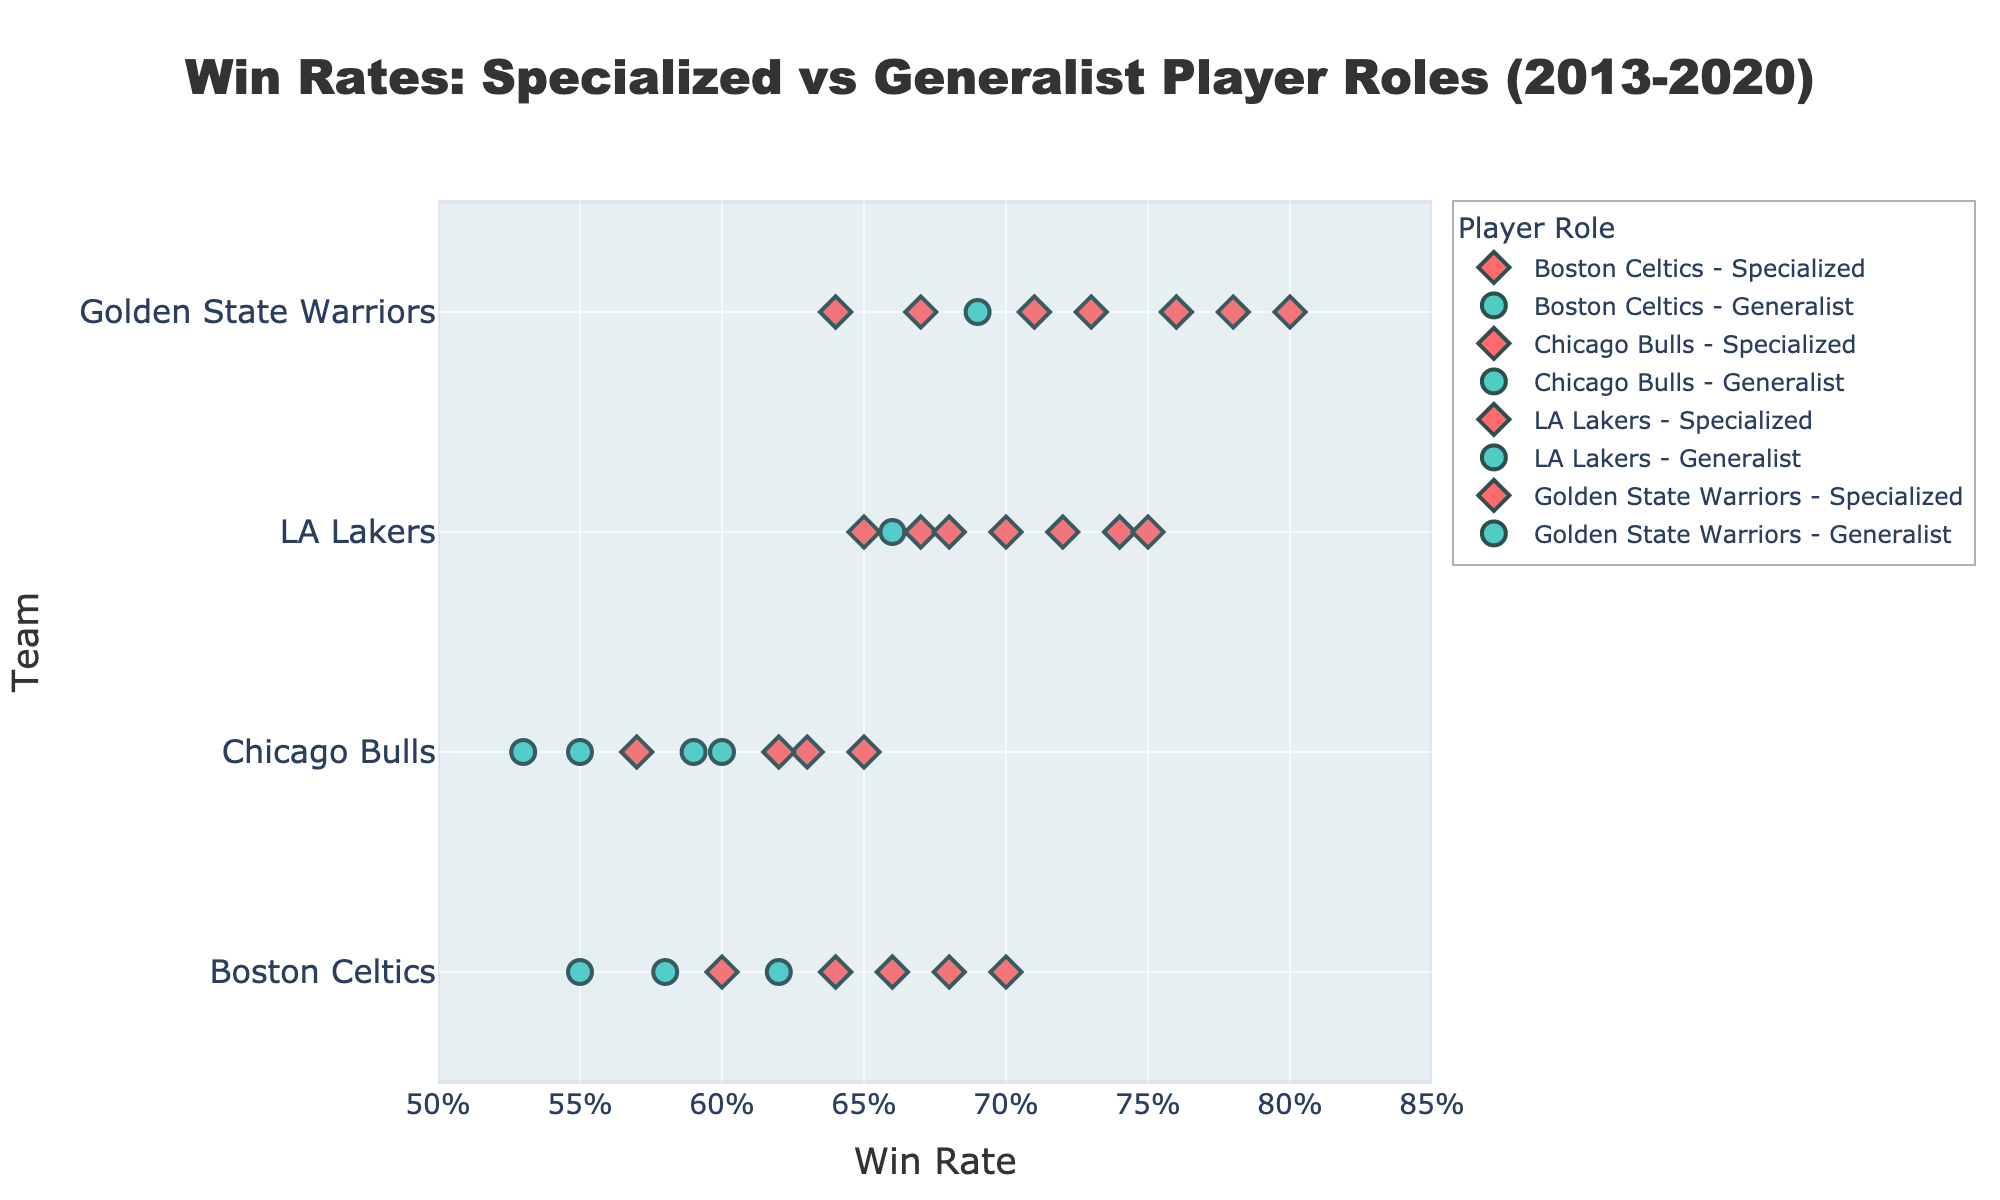Which team had the highest win rate with specialized player roles in 2020? To find the team with the highest win rate with specialized players in 2020, look for the data point in the figure representing specialized roles in 2020 and compare the win rates. The Golden State Warriors had the highest win rate with a specialized role at 0.71 in 2020.
Answer: Golden State Warriors What's the win rate difference between Chicago Bulls with specialized roles in 2014 and generalist roles in 2019? To calculate the win rate difference, find the win rates for Chicago Bulls in 2014 (specialized) and 2019 (generalist) from the figure. The win rates are 0.63 and 0.53, respectively. The difference is 0.63 - 0.53.
Answer: 0.10 Which team showed the most consistent win rates with specialized player roles over the period? Consistency can be observed by looking at the variation in win rates over the years for specialized player roles within each team. The LA Lakers have the least variation in their specialized win rates, ranging between 0.65 and 0.75 over the years.
Answer: LA Lakers Which team showed the largest improvement in win rate when switching from generalist to specialized roles? Identify the years each team switched from generalist to specialized roles in the figure, and calculate the win rate difference. Boston Celtics switched in 2016 with an increase from 0.58 (2015) to 0.66 (2016), amounting to an improvement of 0.08.
Answer: Boston Celtics How many years did the Golden State Warriors have specialized player roles from 2013 to 2020? Count the number of years shown in the figure where the Golden State Warriors had specialized player roles. They had specialized roles in 2013, 2014, 2015, 2016, 2017, 2018, and 2020.
Answer: 7 Did any team have a win rate impact better or worse than others when changing from one role to another in a specific year? If so, which one, and what was the difference? Analyze the win rates by comparing the years when teams switched roles to see the impact. The Boston Celtics had a significant positive impact when they switched from generalist in 2015 (0.58) to specialized in 2016 (0.66), resulting in an 8% increase.
Answer: Boston Celtics, 0.08 In which year did the LA Lakers achieve their highest win rate with specialized players? Look at the figure to find the year with the highest win rate for the LA Lakers with specialized players. The highest win rate was in 2020 with a win rate of 0.75.
Answer: 2020 